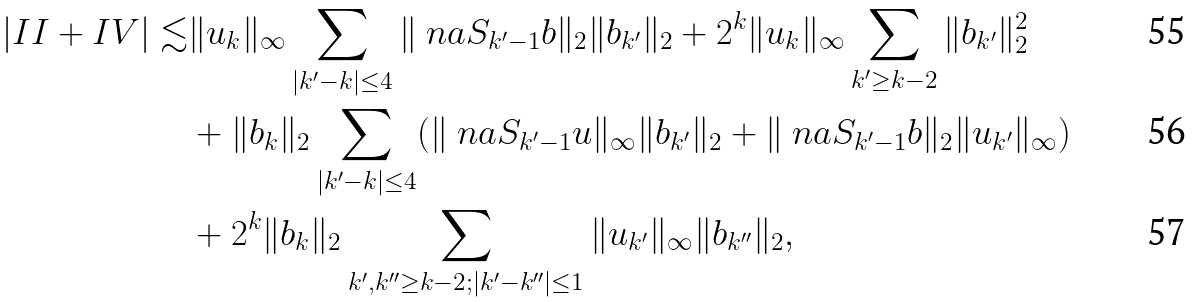<formula> <loc_0><loc_0><loc_500><loc_500>| I I + I V | \lesssim & \| u _ { k } \| _ { \infty } \sum _ { | k ^ { \prime } - k | \leq 4 } \| \ n a S _ { k ^ { \prime } - 1 } b \| _ { 2 } \| b _ { k ^ { \prime } } \| _ { 2 } + 2 ^ { k } \| u _ { k } \| _ { \infty } \sum _ { k ^ { \prime } \geq k - 2 } \| b _ { k ^ { \prime } } \| _ { 2 } ^ { 2 } \\ & + \| b _ { k } \| _ { 2 } \sum _ { | k ^ { \prime } - k | \leq 4 } ( \| \ n a S _ { k ^ { \prime } - 1 } u \| _ { \infty } \| b _ { k ^ { \prime } } \| _ { 2 } + \| \ n a S _ { k ^ { \prime } - 1 } b \| _ { 2 } \| u _ { k ^ { \prime } } \| _ { \infty } ) \\ & + 2 ^ { k } \| b _ { k } \| _ { 2 } \sum _ { k ^ { \prime } , k ^ { \prime \prime } \geq k - 2 ; | k ^ { \prime } - k ^ { \prime \prime } | \leq 1 } \| u _ { k ^ { \prime } } \| _ { \infty } \| b _ { k ^ { \prime \prime } } \| _ { 2 } ,</formula> 